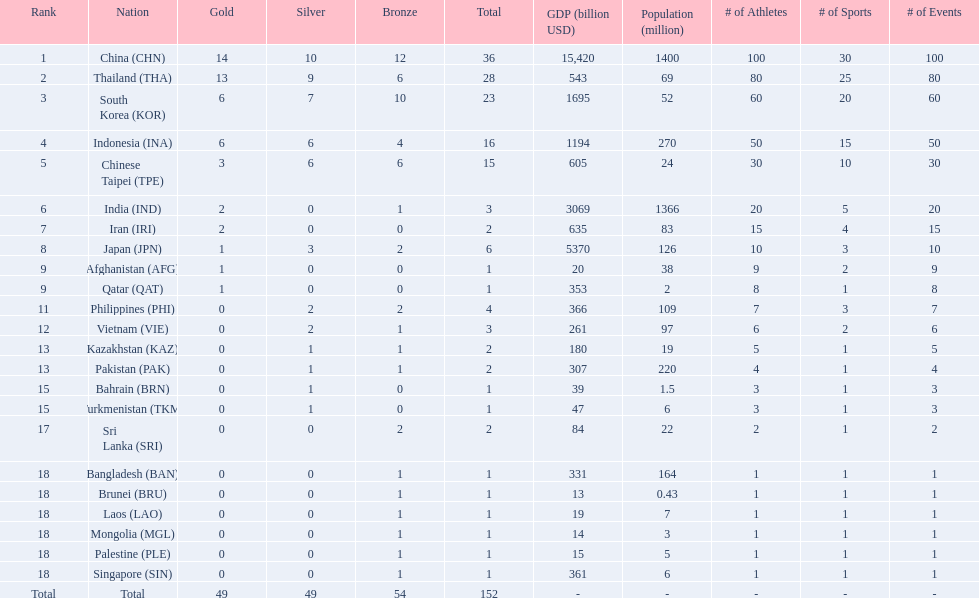What was the number of medals earned by indonesia (ina) ? 16. 